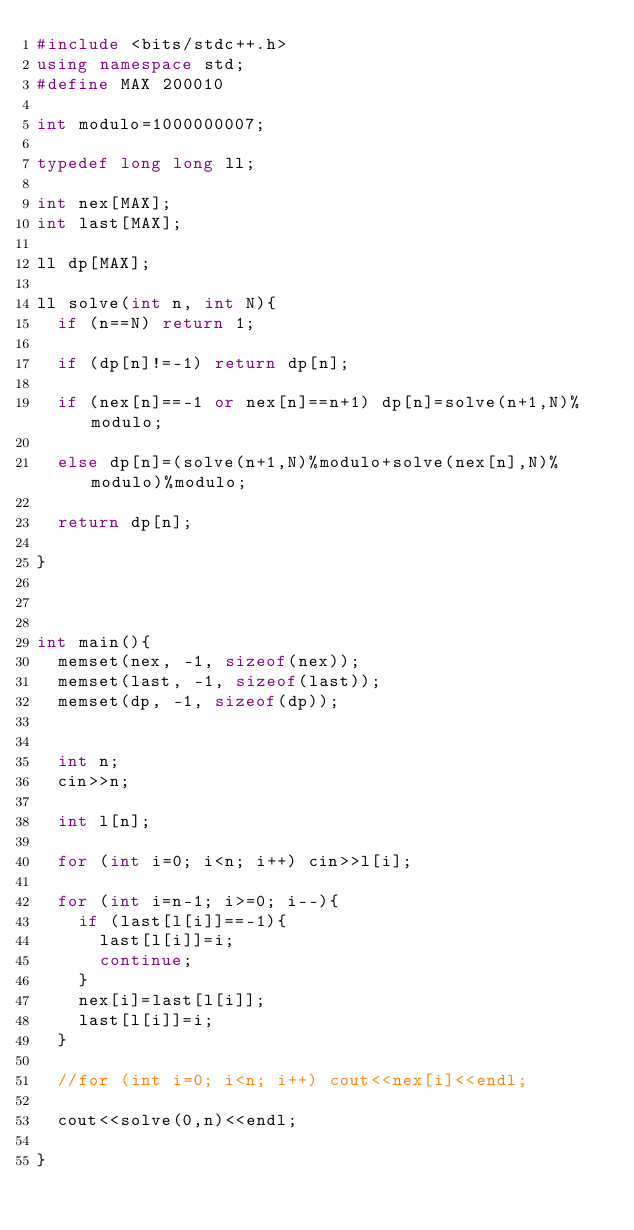<code> <loc_0><loc_0><loc_500><loc_500><_C++_>#include <bits/stdc++.h>
using namespace std;
#define MAX 200010

int modulo=1000000007;

typedef long long ll;

int nex[MAX];
int last[MAX];

ll dp[MAX];

ll solve(int n, int N){
	if (n==N) return 1;
	
	if (dp[n]!=-1) return dp[n];
	
	if (nex[n]==-1 or nex[n]==n+1) dp[n]=solve(n+1,N)%modulo;
	
	else dp[n]=(solve(n+1,N)%modulo+solve(nex[n],N)%modulo)%modulo;
	
	return dp[n];
	
}



int main(){
	memset(nex, -1, sizeof(nex));
	memset(last, -1, sizeof(last));
	memset(dp, -1, sizeof(dp));
	
	
	int n;
	cin>>n;
	
	int l[n];
	
	for (int i=0; i<n; i++) cin>>l[i];
	
	for (int i=n-1; i>=0; i--){
		if (last[l[i]]==-1){
			last[l[i]]=i;
			continue;
		}
		nex[i]=last[l[i]];
		last[l[i]]=i;
	}
	
	//for (int i=0; i<n; i++) cout<<nex[i]<<endl;
	
	cout<<solve(0,n)<<endl;
	
}
</code> 